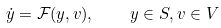Convert formula to latex. <formula><loc_0><loc_0><loc_500><loc_500>\dot { y } = { \mathcal { F } } ( y , v ) , \quad y \in S , v \in V</formula> 